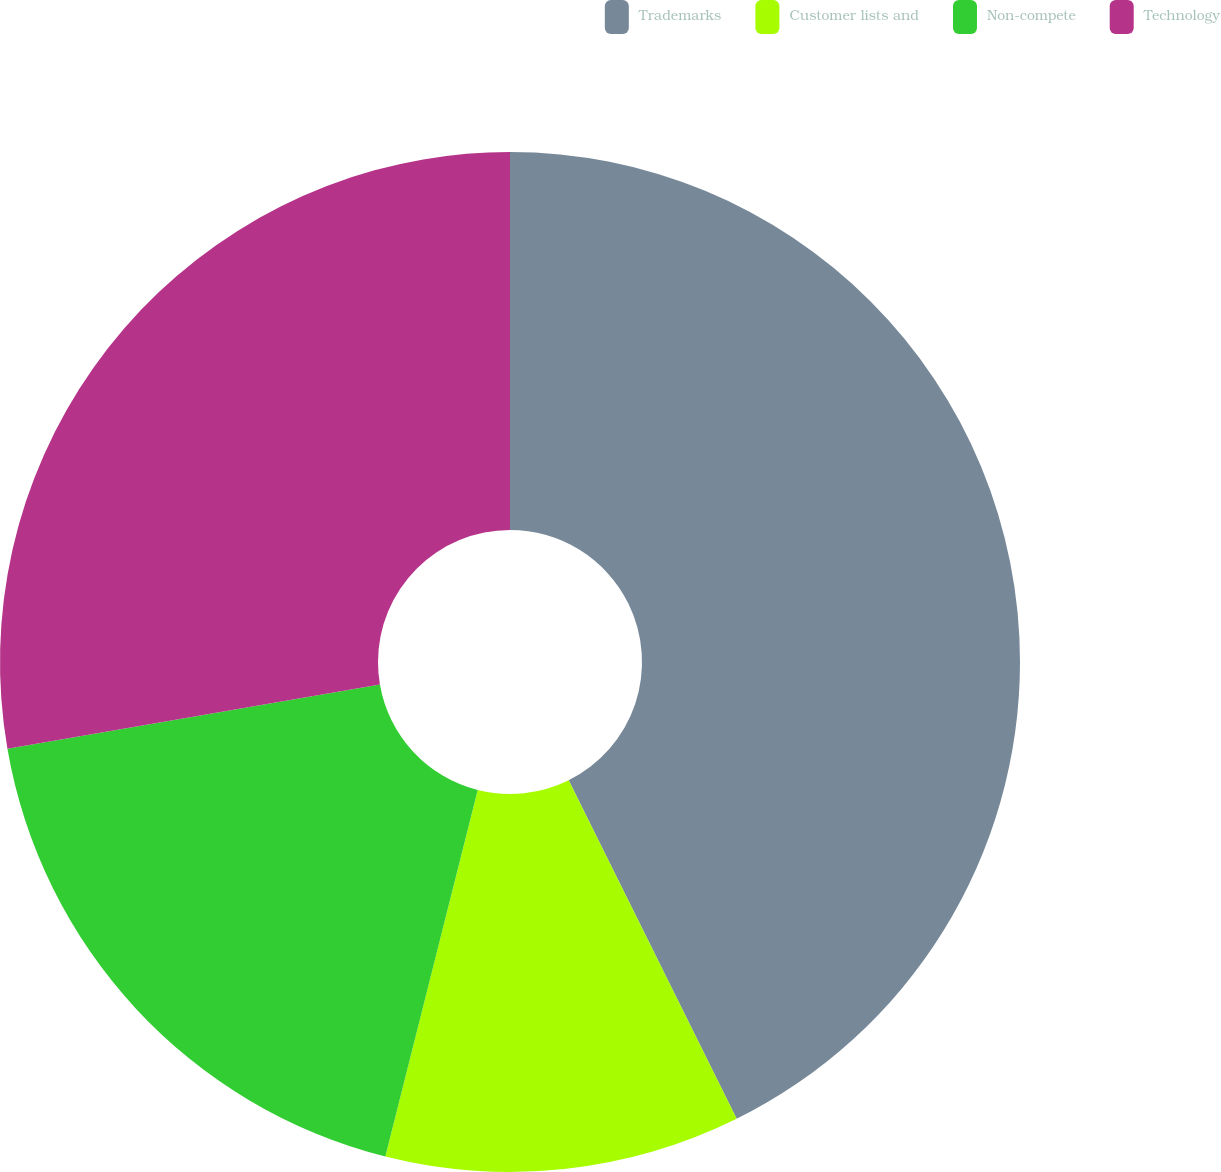<chart> <loc_0><loc_0><loc_500><loc_500><pie_chart><fcel>Trademarks<fcel>Customer lists and<fcel>Non-compete<fcel>Technology<nl><fcel>42.67%<fcel>11.26%<fcel>18.35%<fcel>27.72%<nl></chart> 